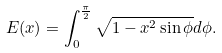Convert formula to latex. <formula><loc_0><loc_0><loc_500><loc_500>E ( x ) = \int _ { 0 } ^ { \frac { \pi } { 2 } } \sqrt { 1 - x ^ { 2 } \sin \phi } d \phi .</formula> 